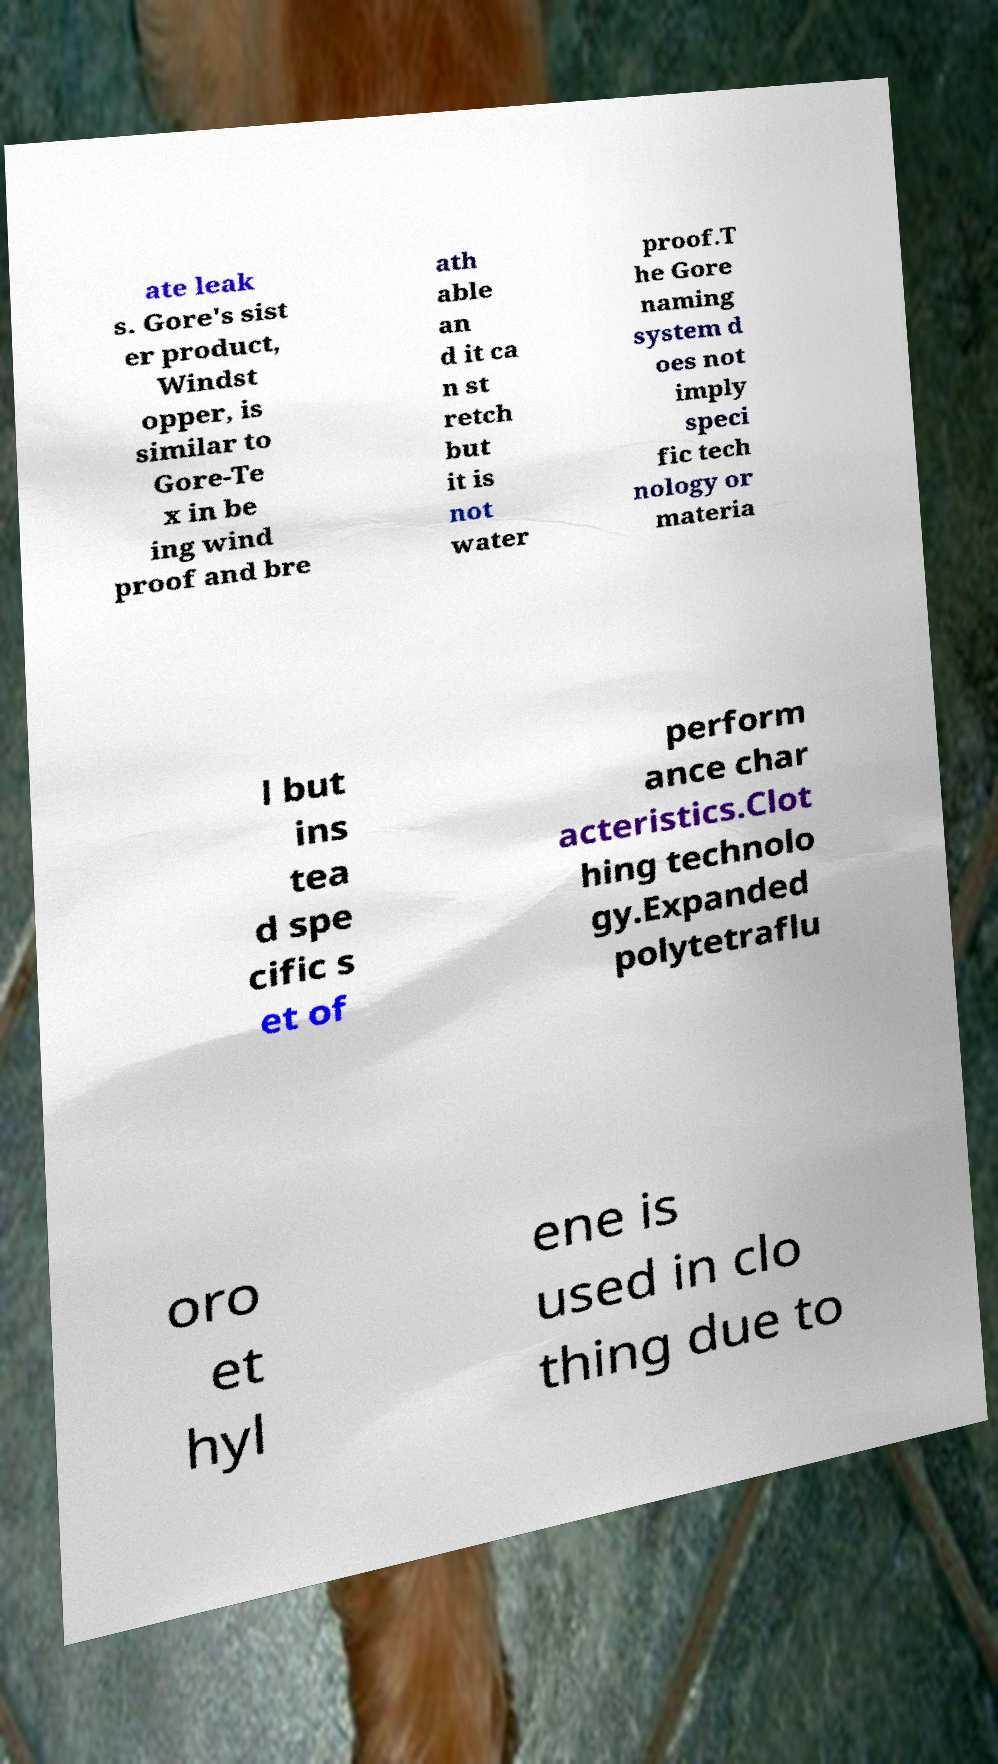There's text embedded in this image that I need extracted. Can you transcribe it verbatim? ate leak s. Gore's sist er product, Windst opper, is similar to Gore-Te x in be ing wind proof and bre ath able an d it ca n st retch but it is not water proof.T he Gore naming system d oes not imply speci fic tech nology or materia l but ins tea d spe cific s et of perform ance char acteristics.Clot hing technolo gy.Expanded polytetraflu oro et hyl ene is used in clo thing due to 